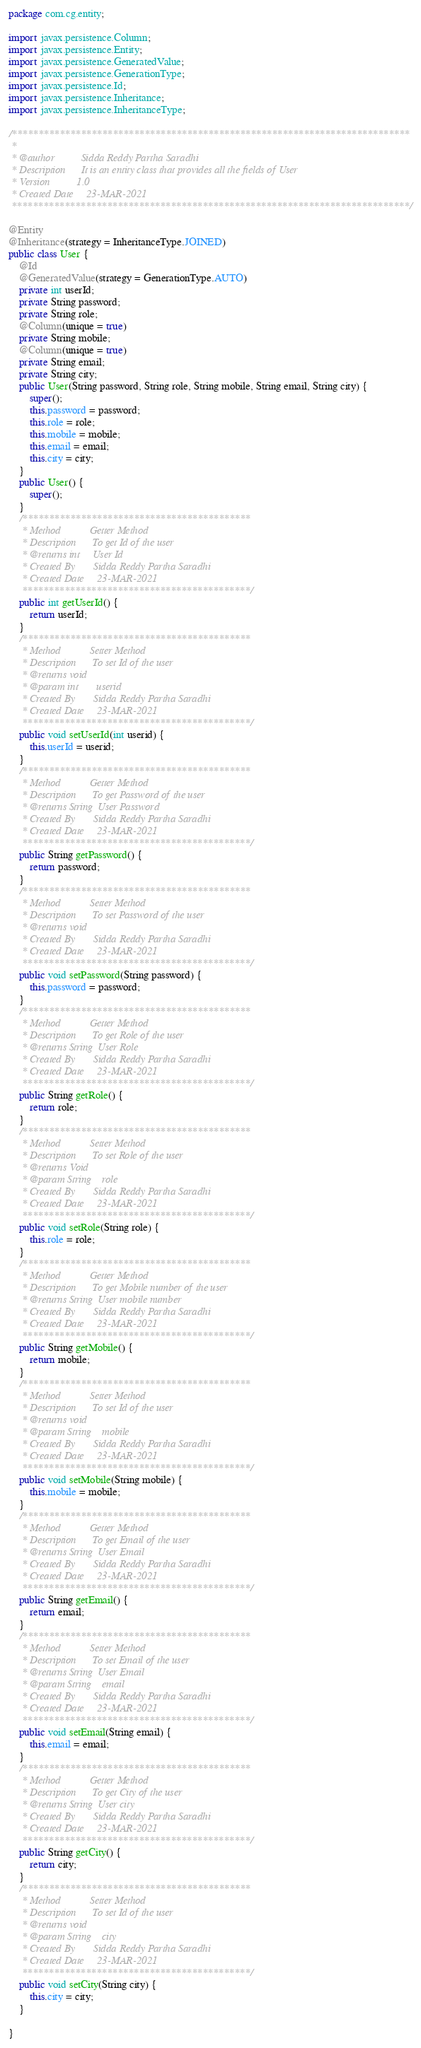<code> <loc_0><loc_0><loc_500><loc_500><_Java_>package com.cg.entity;

import javax.persistence.Column;
import javax.persistence.Entity;
import javax.persistence.GeneratedValue;
import javax.persistence.GenerationType;
import javax.persistence.Id;
import javax.persistence.Inheritance;
import javax.persistence.InheritanceType;

/***************************************************************************
 * 
 * @author 			Sidda Reddy Partha Saradhi
 * Description 		It is an entity class that provides all the fields of User
 * Version			1.0
 * Created Date		23-MAR-2021
 ***************************************************************************/

@Entity
@Inheritance(strategy = InheritanceType.JOINED)
public class User {
	@Id
	@GeneratedValue(strategy = GenerationType.AUTO)
	private int userId;
	private String password;
	private String role;
	@Column(unique = true)
	private String mobile;
	@Column(unique = true)
	private String email;
	private String city;
	public User(String password, String role, String mobile, String email, String city) {
		super();
		this.password = password;
		this.role = role;
		this.mobile = mobile;
		this.email = email;
		this.city = city;
	}
	public User() {
		super();
	}
	/*******************************************
	 * Method			Getter Method
	 * Description 		To get Id of the user
	 * @returns int     User Id
	 * Created By		Sidda Reddy Partha Saradhi
	 * Created Date		23-MAR-2021
	 *******************************************/
	public int getUserId() {
		return userId;
	}
	/*******************************************
	 * Method			Setter Method
	 * Description 		To set Id of the user
	 * @returns void
	 * @param int 		userid
	 * Created By		Sidda Reddy Partha Saradhi
	 * Created Date		23-MAR-2021
	 *******************************************/
	public void setUserId(int userid) {
		this.userId = userid;
	}
	/*******************************************
	 * Method			Getter Method
	 * Description 		To get Password of the user
	 * @returns String  User Password
	 * Created By		Sidda Reddy Partha Saradhi
	 * Created Date		23-MAR-2021
	 *******************************************/
	public String getPassword() {
		return password;
	}
	/*******************************************
	 * Method			Setter Method
	 * Description 		To set Password of the user
	 * @returns void
	 * Created By		Sidda Reddy Partha Saradhi
	 * Created Date		23-MAR-2021
	 *******************************************/
	public void setPassword(String password) {
		this.password = password;
	}
	/*******************************************
	 * Method			Getter Method
	 * Description 		To get Role of the user
	 * @returns String	User Role
	 * Created By		Sidda Reddy Partha Saradhi
	 * Created Date		23-MAR-2021
	 *******************************************/
	public String getRole() {
		return role;
	}
	/*******************************************
	 * Method			Setter Method
	 * Description 		To set Role of the user
	 * @returns Void    
	 * @param String	role
	 * Created By		Sidda Reddy Partha Saradhi
	 * Created Date		23-MAR-2021
	 *******************************************/
	public void setRole(String role) {
		this.role = role;
	}
	/*******************************************
	 * Method			Getter Method
	 * Description 		To get Mobile number of the user
	 * @returns String  User mobile number
	 * Created By		Sidda Reddy Partha Saradhi
	 * Created Date		23-MAR-2021
	 *******************************************/
	public String getMobile() {
		return mobile;
	}
	/*******************************************
	 * Method			Setter Method
	 * Description 		To set Id of the user
	 * @returns void
	 * @param String	mobile
	 * Created By		Sidda Reddy Partha Saradhi
	 * Created Date		23-MAR-2021
	 *******************************************/
	public void setMobile(String mobile) {
		this.mobile = mobile;
	}
	/*******************************************
	 * Method			Getter Method
	 * Description 		To get Email of the user
	 * @returns String  User Email
	 * Created By		Sidda Reddy Partha Saradhi
	 * Created Date		23-MAR-2021
	 *******************************************/
	public String getEmail() {
		return email;
	}
	/*******************************************
	 * Method			Setter Method
	 * Description 		To set Email of the user
	 * @returns String  User Email
	 * @param String	email
	 * Created By		Sidda Reddy Partha Saradhi
	 * Created Date		23-MAR-2021
	 *******************************************/
	public void setEmail(String email) {
		this.email = email;
	}
	/*******************************************
	 * Method			Getter Method
	 * Description 		To get City of the user
	 * @returns String  User city
	 * Created By		Sidda Reddy Partha Saradhi
	 * Created Date		23-MAR-2021
	 *******************************************/
	public String getCity() {
		return city;
	}
	/*******************************************
	 * Method			Setter Method
	 * Description 		To set Id of the user
	 * @returns void
	 * @param String 	city
	 * Created By		Sidda Reddy Partha Saradhi
	 * Created Date		23-MAR-2021
	 *******************************************/
	public void setCity(String city) {
		this.city = city;
	}
	
}
</code> 